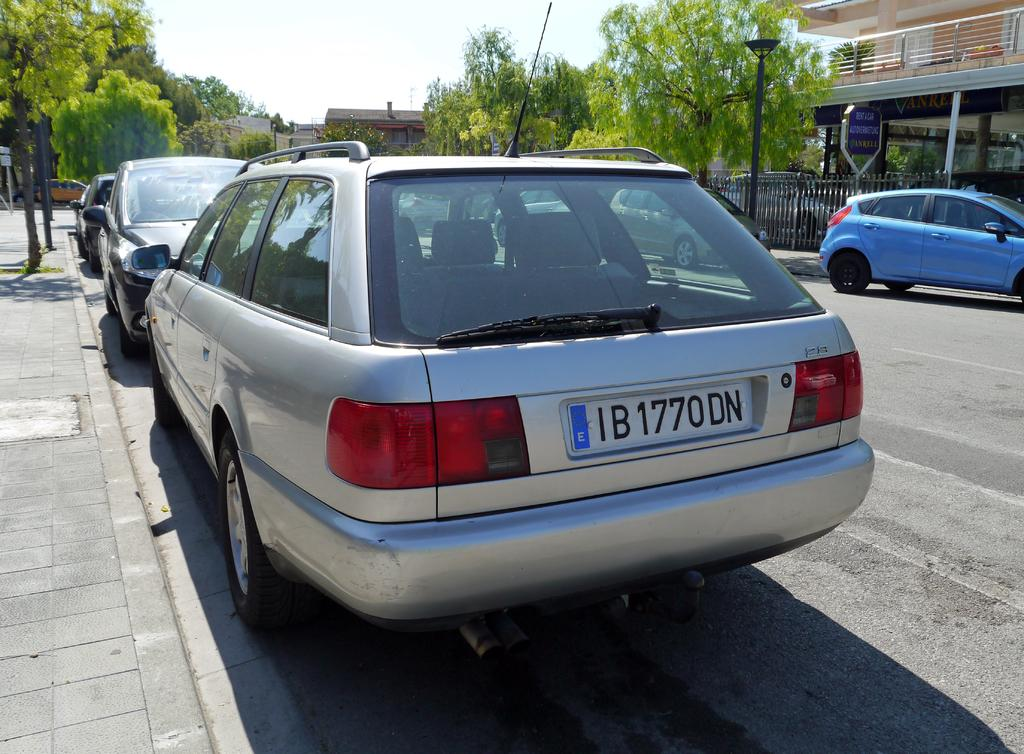<image>
Render a clear and concise summary of the photo. A back of a foreign car shows it's a 2S model. 